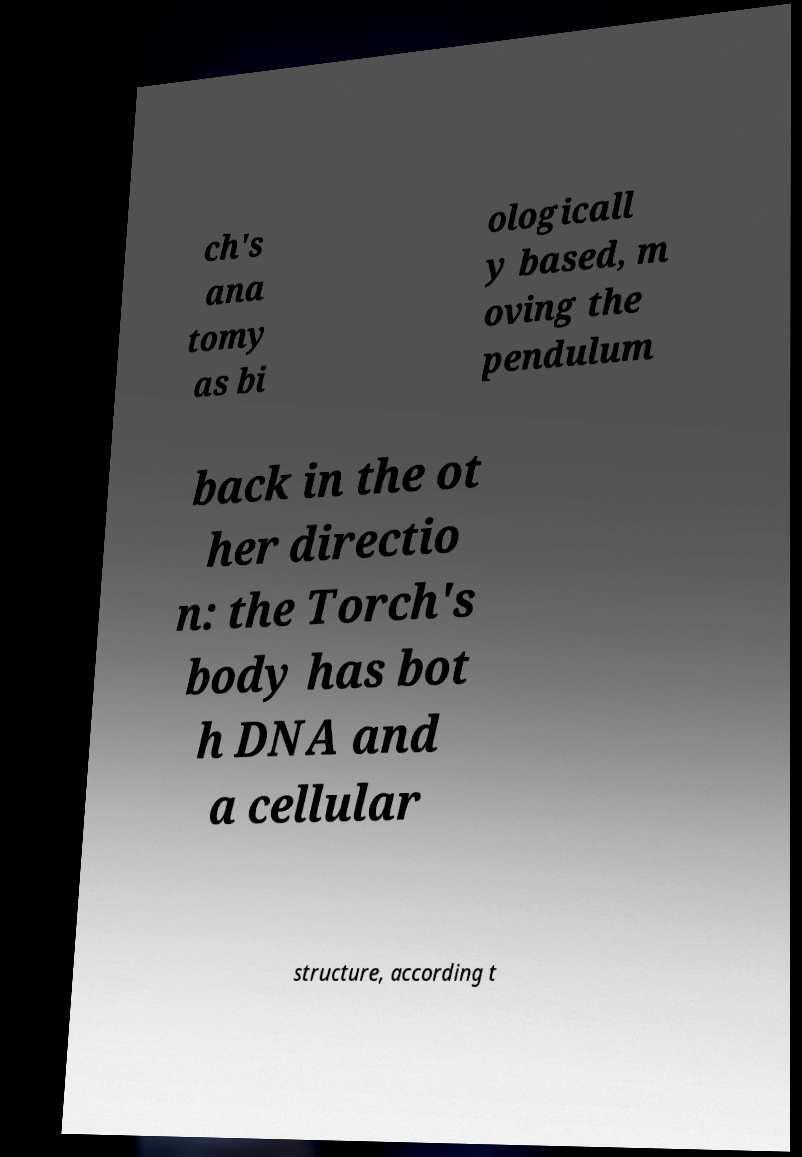I need the written content from this picture converted into text. Can you do that? ch's ana tomy as bi ologicall y based, m oving the pendulum back in the ot her directio n: the Torch's body has bot h DNA and a cellular structure, according t 